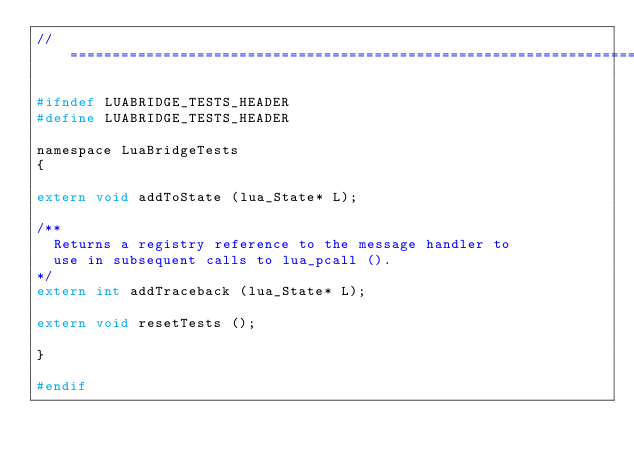Convert code to text. <code><loc_0><loc_0><loc_500><loc_500><_C_>//==============================================================================

#ifndef LUABRIDGE_TESTS_HEADER
#define LUABRIDGE_TESTS_HEADER

namespace LuaBridgeTests
{

extern void addToState (lua_State* L);

/**
  Returns a registry reference to the message handler to
  use in subsequent calls to lua_pcall ().
*/
extern int addTraceback (lua_State* L);

extern void resetTests ();

}

#endif
</code> 